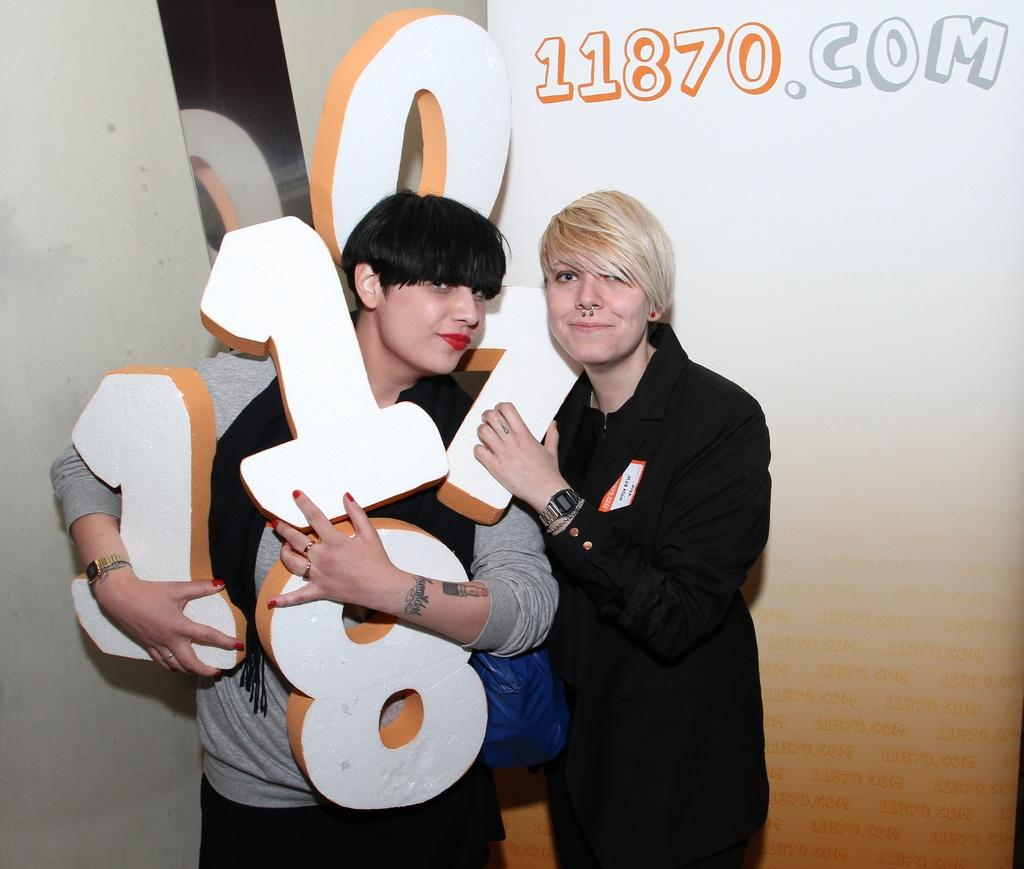How many people are in the image? There are two persons standing in the image. What are the persons holding in their hands? The persons are holding digits. Where are the persons standing? The persons are standing on the floor. What can be seen in the background of the image? There is a wall visible in the background of the image. Can you see a giraffe or a boat in the image? No, there is no giraffe or boat present in the image. Is there a light source visible in the image? The provided facts do not mention any light source, so we cannot determine if one is visible in the image. 